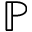<formula> <loc_0><loc_0><loc_500><loc_500>\mathbb { P }</formula> 